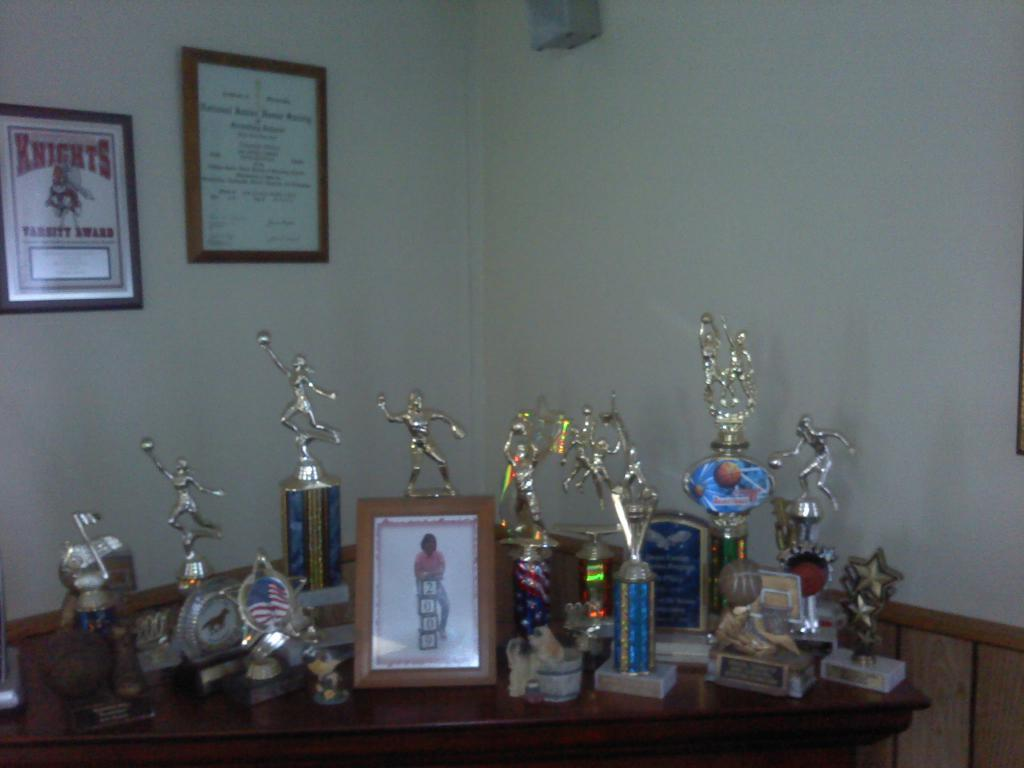What objects can be seen on the table in the image? There are mementos on a table in the image. What is hanging on the wall in the image? There is a frame on a wall in the image. What type of chalk is being used to write on the mailbox in the image? There is no chalk or mailbox present in the image. What kind of drink is being served in the image? There is no drink being served in the image. 